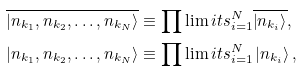<formula> <loc_0><loc_0><loc_500><loc_500>\overline { \left | n _ { k _ { 1 } } , n _ { k _ { 2 } } , \dots , n _ { k _ { N } } \right \rangle } & \equiv \prod \lim i t s _ { i = 1 } ^ { N } \overline { \left | n _ { k _ { i } } \right \rangle } , \\ \left | n _ { k _ { 1 } } , n _ { k _ { 2 } } , \dots , n _ { k _ { N } } \right \rangle & \equiv \prod \lim i t s _ { i = 1 } ^ { N } \left | n _ { k _ { i } } \right \rangle ,</formula> 